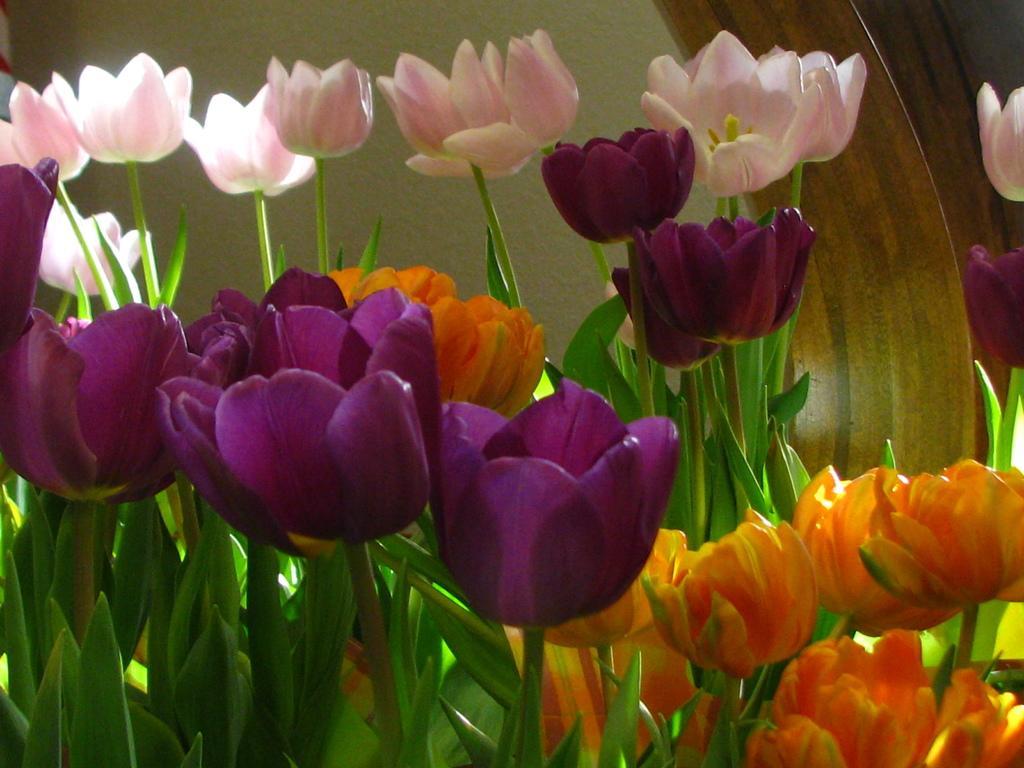Describe this image in one or two sentences. In this image we can see different colors of tulips. In the background there is a wall and we can see leaves. 